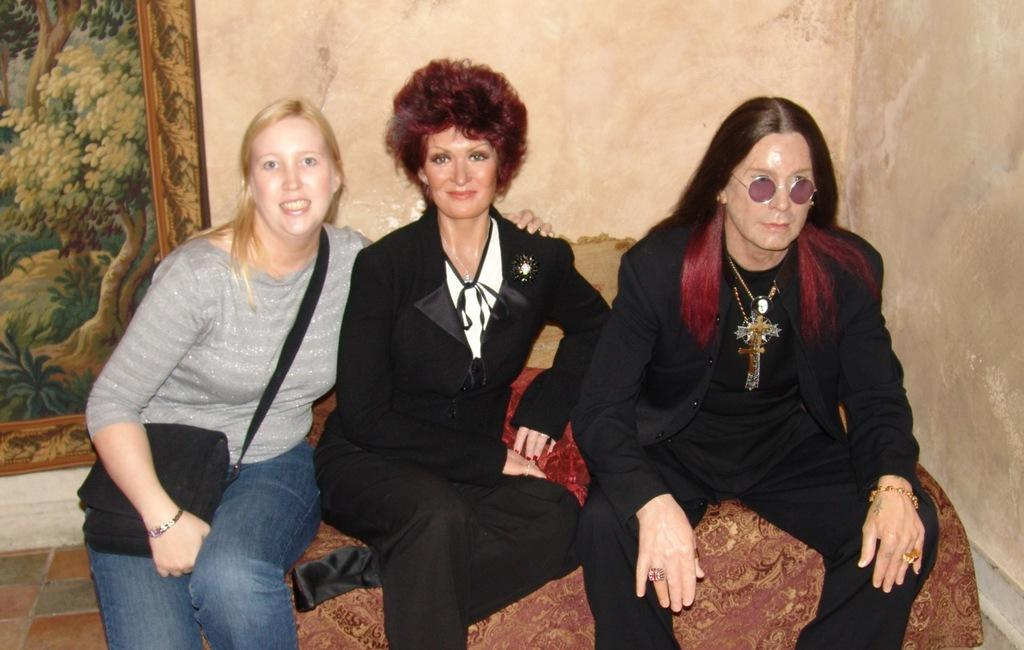How many people are sitting on the sofa in the image? There are three people sitting on the sofa in the image. What can be seen in the background of the image? There is a wall in the background of the image. Is there any decoration or object on the wall? Yes, there is a frame placed on the wall. What part of the room is visible at the bottom of the image? The floor is visible at the bottom of the image. What type of test is being conducted on the sofa in the image? There is no test being conducted in the image; it shows three people sitting on a sofa. 